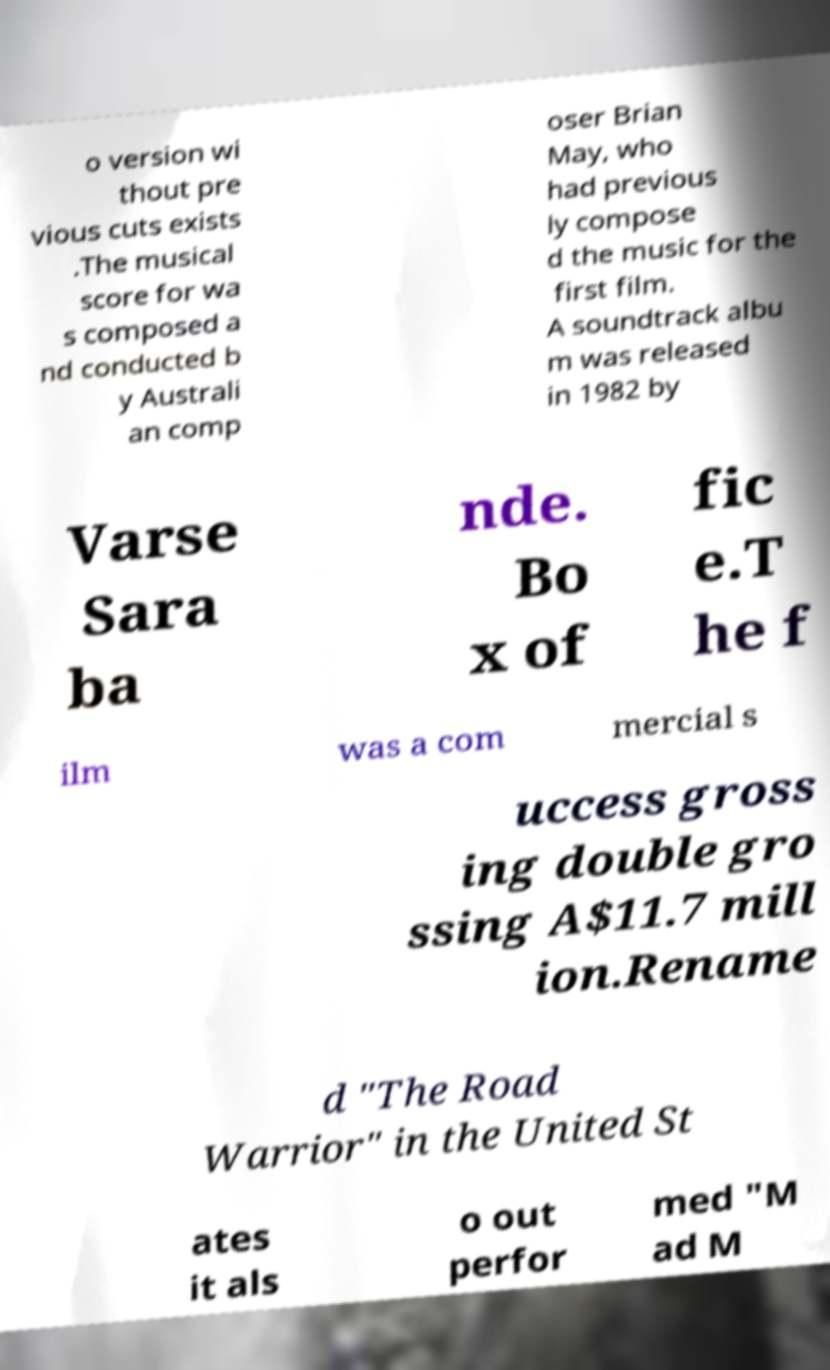I need the written content from this picture converted into text. Can you do that? o version wi thout pre vious cuts exists .The musical score for wa s composed a nd conducted b y Australi an comp oser Brian May, who had previous ly compose d the music for the first film. A soundtrack albu m was released in 1982 by Varse Sara ba nde. Bo x of fic e.T he f ilm was a com mercial s uccess gross ing double gro ssing A$11.7 mill ion.Rename d "The Road Warrior" in the United St ates it als o out perfor med "M ad M 